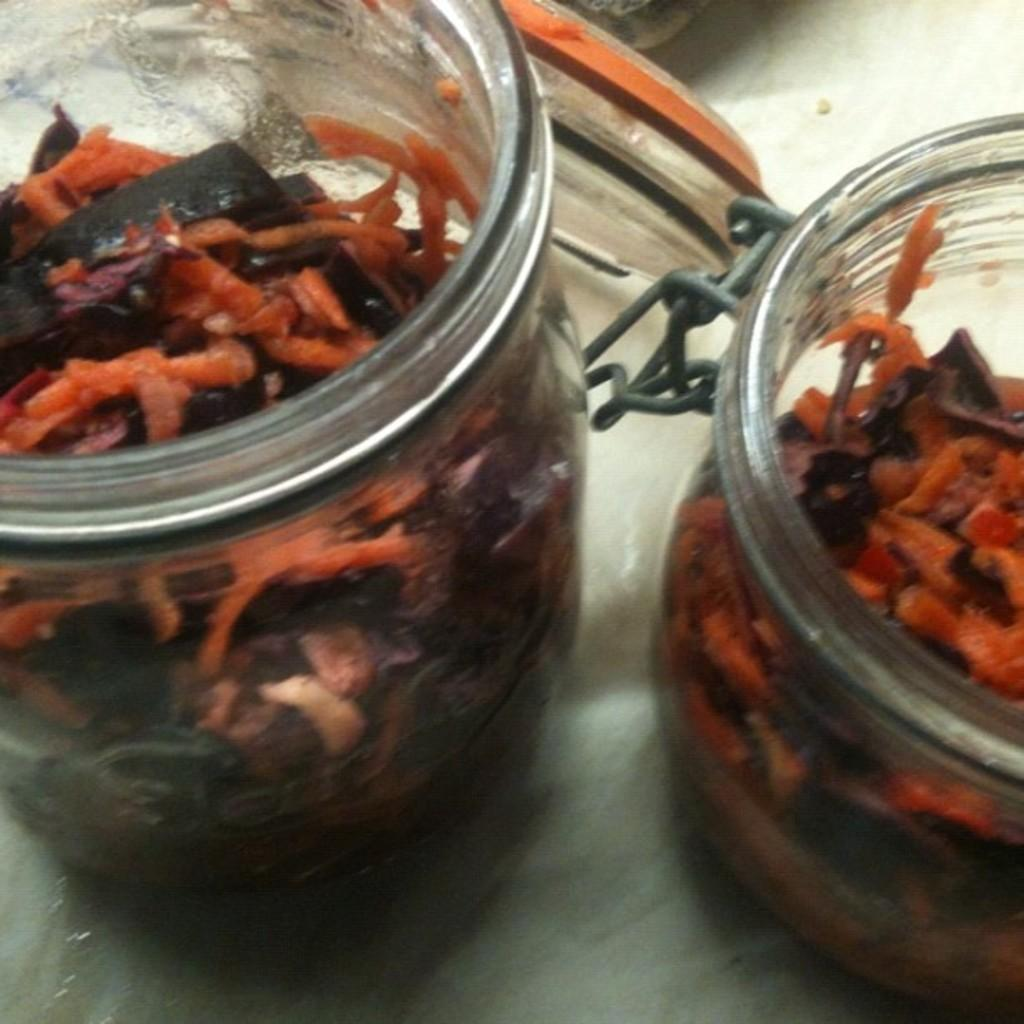What type of food can be seen in the image? The food in jars can be seen in the image. Where is the food in jars located in the image? The food in jars is in the center of the image. What type of chalk is being used to create art in the image? There is no chalk or art present in the image; it only features food in jars. What is the middle of the image used for in the image? The middle of the image is not used for anything specific in the image; it simply contains the food in jars. 